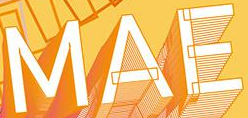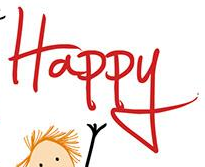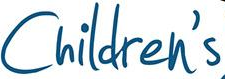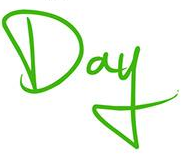What text appears in these images from left to right, separated by a semicolon? MAE; Happy; Children's; Day 